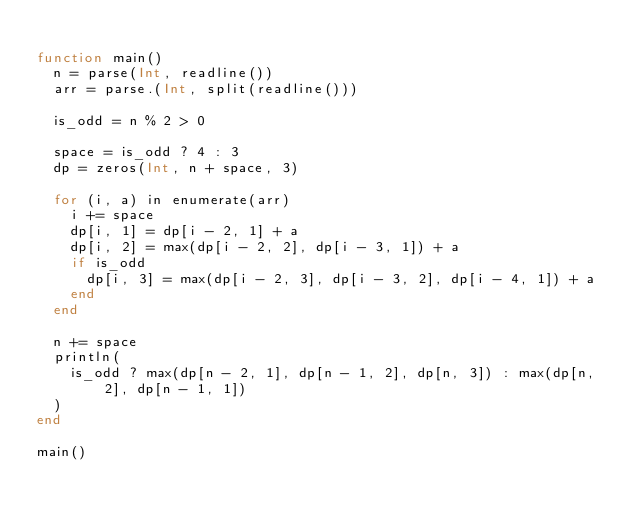<code> <loc_0><loc_0><loc_500><loc_500><_Julia_>
function main()
  n = parse(Int, readline())
  arr = parse.(Int, split(readline()))

  is_odd = n % 2 > 0

  space = is_odd ? 4 : 3
  dp = zeros(Int, n + space, 3)

  for (i, a) in enumerate(arr)
    i += space
    dp[i, 1] = dp[i - 2, 1] + a
    dp[i, 2] = max(dp[i - 2, 2], dp[i - 3, 1]) + a
    if is_odd
      dp[i, 3] = max(dp[i - 2, 3], dp[i - 3, 2], dp[i - 4, 1]) + a
    end
  end

  n += space
  println(
    is_odd ? max(dp[n - 2, 1], dp[n - 1, 2], dp[n, 3]) : max(dp[n, 2], dp[n - 1, 1])
  )
end

main()
</code> 